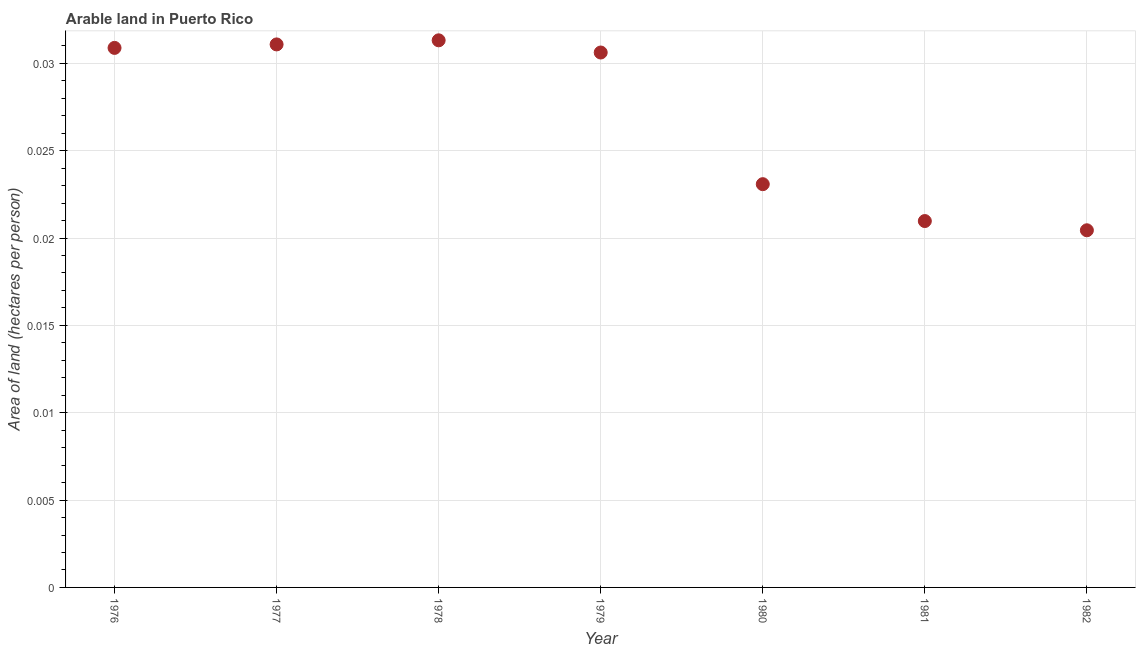What is the area of arable land in 1976?
Offer a very short reply. 0.03. Across all years, what is the maximum area of arable land?
Keep it short and to the point. 0.03. Across all years, what is the minimum area of arable land?
Your answer should be very brief. 0.02. In which year was the area of arable land maximum?
Provide a short and direct response. 1978. What is the sum of the area of arable land?
Offer a very short reply. 0.19. What is the difference between the area of arable land in 1978 and 1982?
Offer a terse response. 0.01. What is the average area of arable land per year?
Ensure brevity in your answer.  0.03. What is the median area of arable land?
Ensure brevity in your answer.  0.03. Do a majority of the years between 1980 and 1981 (inclusive) have area of arable land greater than 0.016 hectares per person?
Provide a succinct answer. Yes. What is the ratio of the area of arable land in 1978 to that in 1979?
Keep it short and to the point. 1.02. Is the area of arable land in 1980 less than that in 1981?
Offer a terse response. No. Is the difference between the area of arable land in 1979 and 1980 greater than the difference between any two years?
Keep it short and to the point. No. What is the difference between the highest and the second highest area of arable land?
Make the answer very short. 0. Is the sum of the area of arable land in 1978 and 1979 greater than the maximum area of arable land across all years?
Ensure brevity in your answer.  Yes. What is the difference between the highest and the lowest area of arable land?
Provide a short and direct response. 0.01. Does the area of arable land monotonically increase over the years?
Provide a succinct answer. No. What is the difference between two consecutive major ticks on the Y-axis?
Offer a very short reply. 0.01. Are the values on the major ticks of Y-axis written in scientific E-notation?
Make the answer very short. No. Does the graph contain any zero values?
Provide a succinct answer. No. Does the graph contain grids?
Offer a very short reply. Yes. What is the title of the graph?
Your response must be concise. Arable land in Puerto Rico. What is the label or title of the Y-axis?
Ensure brevity in your answer.  Area of land (hectares per person). What is the Area of land (hectares per person) in 1976?
Give a very brief answer. 0.03. What is the Area of land (hectares per person) in 1977?
Offer a terse response. 0.03. What is the Area of land (hectares per person) in 1978?
Your response must be concise. 0.03. What is the Area of land (hectares per person) in 1979?
Offer a terse response. 0.03. What is the Area of land (hectares per person) in 1980?
Your answer should be compact. 0.02. What is the Area of land (hectares per person) in 1981?
Offer a terse response. 0.02. What is the Area of land (hectares per person) in 1982?
Ensure brevity in your answer.  0.02. What is the difference between the Area of land (hectares per person) in 1976 and 1977?
Keep it short and to the point. -0. What is the difference between the Area of land (hectares per person) in 1976 and 1978?
Ensure brevity in your answer.  -0. What is the difference between the Area of land (hectares per person) in 1976 and 1979?
Your response must be concise. 0. What is the difference between the Area of land (hectares per person) in 1976 and 1980?
Your answer should be very brief. 0.01. What is the difference between the Area of land (hectares per person) in 1976 and 1981?
Offer a terse response. 0.01. What is the difference between the Area of land (hectares per person) in 1976 and 1982?
Give a very brief answer. 0.01. What is the difference between the Area of land (hectares per person) in 1977 and 1978?
Offer a terse response. -0. What is the difference between the Area of land (hectares per person) in 1977 and 1979?
Keep it short and to the point. 0. What is the difference between the Area of land (hectares per person) in 1977 and 1980?
Your answer should be compact. 0.01. What is the difference between the Area of land (hectares per person) in 1977 and 1981?
Keep it short and to the point. 0.01. What is the difference between the Area of land (hectares per person) in 1977 and 1982?
Keep it short and to the point. 0.01. What is the difference between the Area of land (hectares per person) in 1978 and 1979?
Your answer should be compact. 0. What is the difference between the Area of land (hectares per person) in 1978 and 1980?
Your answer should be compact. 0.01. What is the difference between the Area of land (hectares per person) in 1978 and 1981?
Keep it short and to the point. 0.01. What is the difference between the Area of land (hectares per person) in 1978 and 1982?
Keep it short and to the point. 0.01. What is the difference between the Area of land (hectares per person) in 1979 and 1980?
Give a very brief answer. 0.01. What is the difference between the Area of land (hectares per person) in 1979 and 1981?
Offer a very short reply. 0.01. What is the difference between the Area of land (hectares per person) in 1979 and 1982?
Your answer should be compact. 0.01. What is the difference between the Area of land (hectares per person) in 1980 and 1981?
Give a very brief answer. 0. What is the difference between the Area of land (hectares per person) in 1980 and 1982?
Your answer should be compact. 0. What is the difference between the Area of land (hectares per person) in 1981 and 1982?
Keep it short and to the point. 0. What is the ratio of the Area of land (hectares per person) in 1976 to that in 1977?
Provide a succinct answer. 0.99. What is the ratio of the Area of land (hectares per person) in 1976 to that in 1978?
Provide a short and direct response. 0.99. What is the ratio of the Area of land (hectares per person) in 1976 to that in 1979?
Offer a terse response. 1.01. What is the ratio of the Area of land (hectares per person) in 1976 to that in 1980?
Keep it short and to the point. 1.34. What is the ratio of the Area of land (hectares per person) in 1976 to that in 1981?
Ensure brevity in your answer.  1.47. What is the ratio of the Area of land (hectares per person) in 1976 to that in 1982?
Your response must be concise. 1.51. What is the ratio of the Area of land (hectares per person) in 1977 to that in 1978?
Offer a very short reply. 0.99. What is the ratio of the Area of land (hectares per person) in 1977 to that in 1980?
Your response must be concise. 1.35. What is the ratio of the Area of land (hectares per person) in 1977 to that in 1981?
Make the answer very short. 1.48. What is the ratio of the Area of land (hectares per person) in 1977 to that in 1982?
Your answer should be very brief. 1.52. What is the ratio of the Area of land (hectares per person) in 1978 to that in 1980?
Give a very brief answer. 1.36. What is the ratio of the Area of land (hectares per person) in 1978 to that in 1981?
Offer a very short reply. 1.49. What is the ratio of the Area of land (hectares per person) in 1978 to that in 1982?
Give a very brief answer. 1.53. What is the ratio of the Area of land (hectares per person) in 1979 to that in 1980?
Provide a succinct answer. 1.33. What is the ratio of the Area of land (hectares per person) in 1979 to that in 1981?
Keep it short and to the point. 1.46. What is the ratio of the Area of land (hectares per person) in 1979 to that in 1982?
Your response must be concise. 1.5. What is the ratio of the Area of land (hectares per person) in 1980 to that in 1981?
Give a very brief answer. 1.1. What is the ratio of the Area of land (hectares per person) in 1980 to that in 1982?
Your response must be concise. 1.13. 